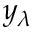<formula> <loc_0><loc_0><loc_500><loc_500>y _ { \lambda }</formula> 